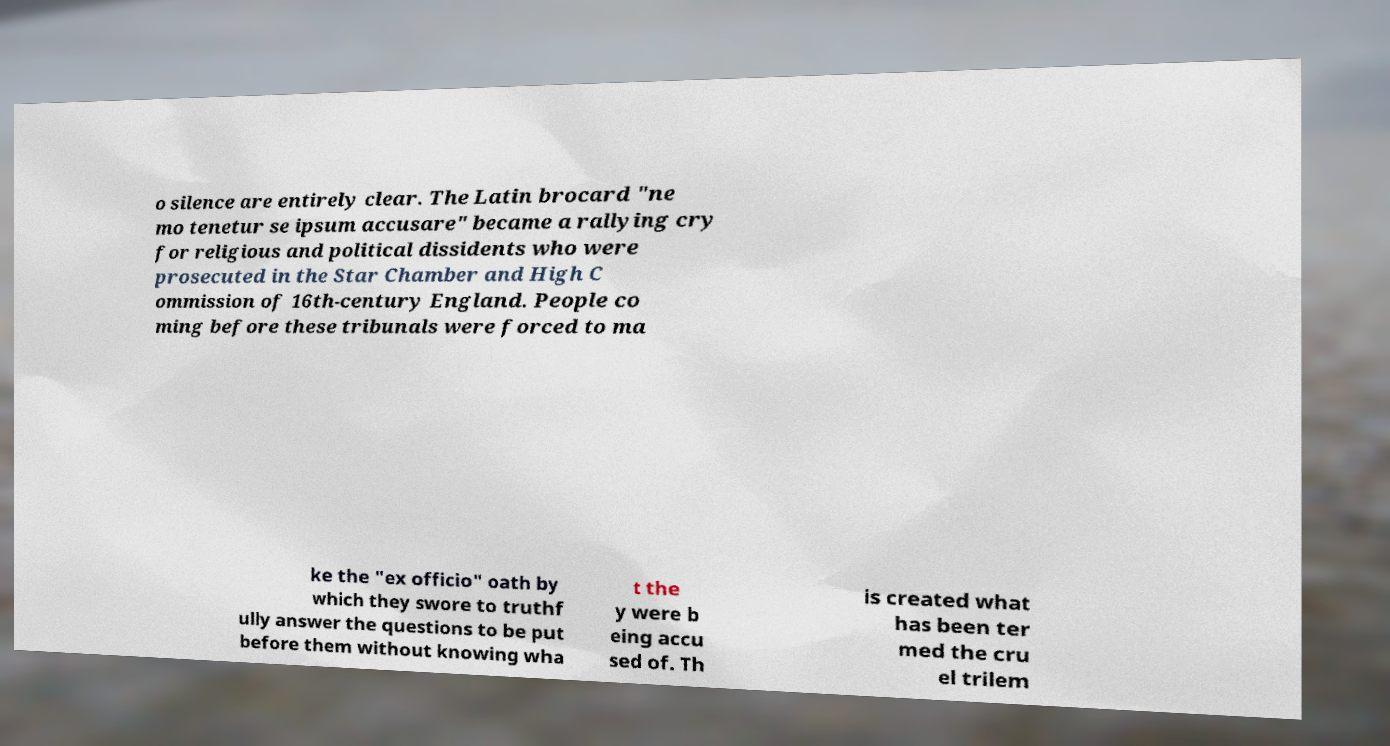Could you extract and type out the text from this image? o silence are entirely clear. The Latin brocard "ne mo tenetur se ipsum accusare" became a rallying cry for religious and political dissidents who were prosecuted in the Star Chamber and High C ommission of 16th-century England. People co ming before these tribunals were forced to ma ke the "ex officio" oath by which they swore to truthf ully answer the questions to be put before them without knowing wha t the y were b eing accu sed of. Th is created what has been ter med the cru el trilem 